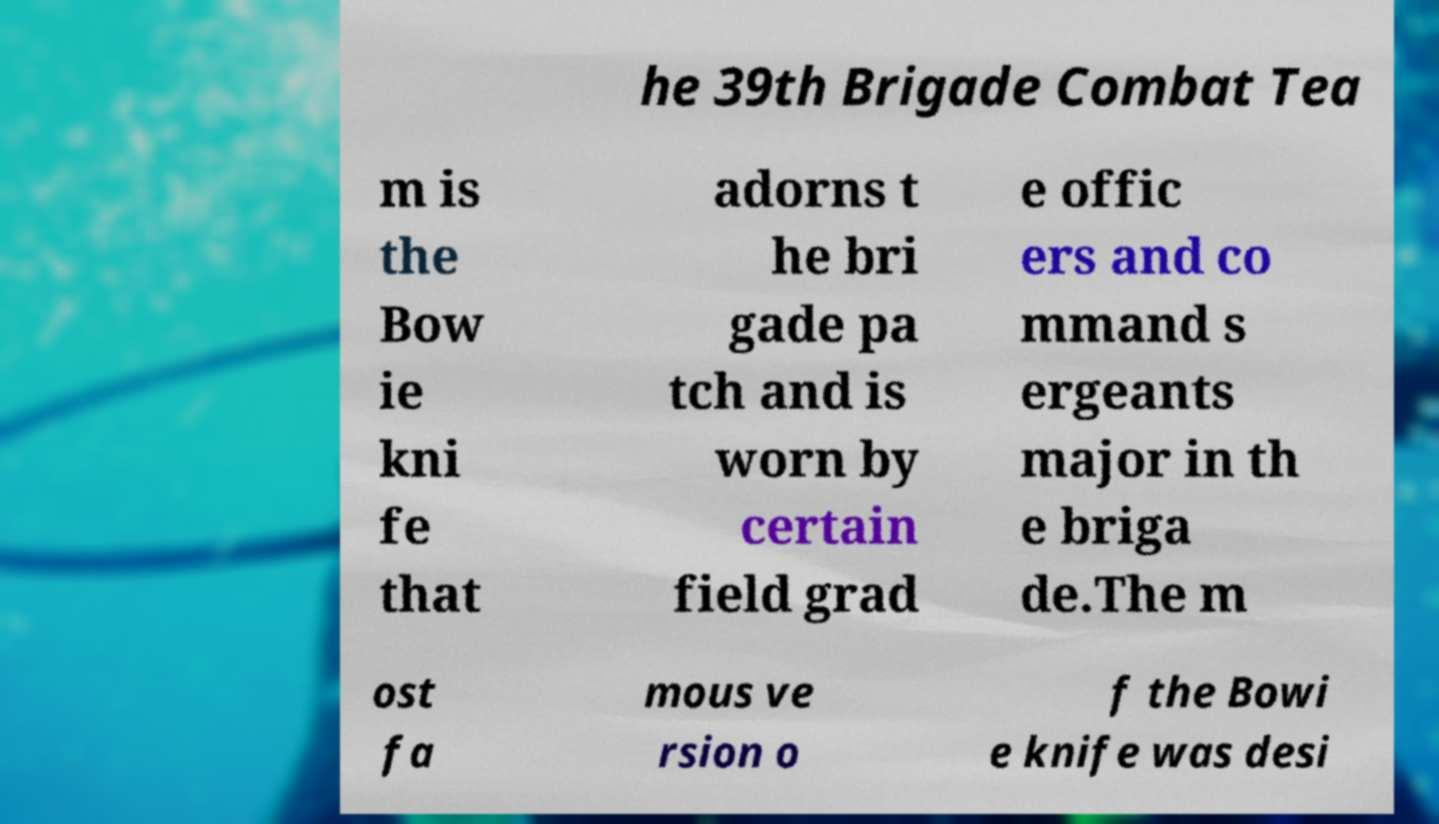Please identify and transcribe the text found in this image. he 39th Brigade Combat Tea m is the Bow ie kni fe that adorns t he bri gade pa tch and is worn by certain field grad e offic ers and co mmand s ergeants major in th e briga de.The m ost fa mous ve rsion o f the Bowi e knife was desi 